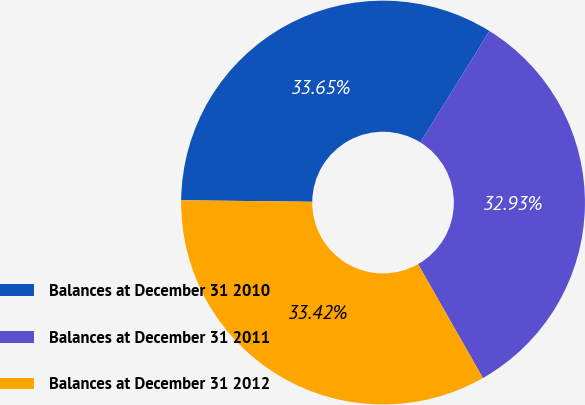Convert chart. <chart><loc_0><loc_0><loc_500><loc_500><pie_chart><fcel>Balances at December 31 2010<fcel>Balances at December 31 2011<fcel>Balances at December 31 2012<nl><fcel>33.65%<fcel>32.93%<fcel>33.42%<nl></chart> 